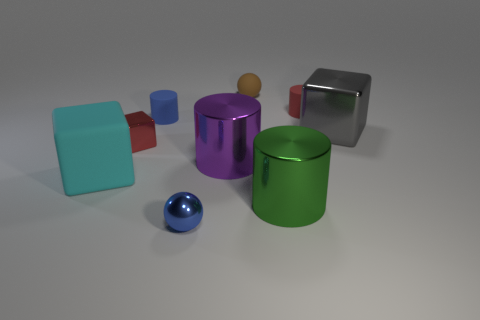Subtract all metallic cubes. How many cubes are left? 1 Subtract all purple cylinders. How many cylinders are left? 3 Subtract 2 cylinders. How many cylinders are left? 2 Subtract all green cylinders. Subtract all blue cubes. How many cylinders are left? 3 Subtract all cylinders. How many objects are left? 5 Add 7 big blue metallic things. How many big blue metallic things exist? 7 Subtract 0 cyan cylinders. How many objects are left? 9 Subtract all cyan objects. Subtract all cylinders. How many objects are left? 4 Add 2 large cyan blocks. How many large cyan blocks are left? 3 